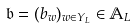<formula> <loc_0><loc_0><loc_500><loc_500>\mathfrak b = ( b _ { w } ) _ { w \in Y _ { L } } \in \mathbb { A } _ { L }</formula> 